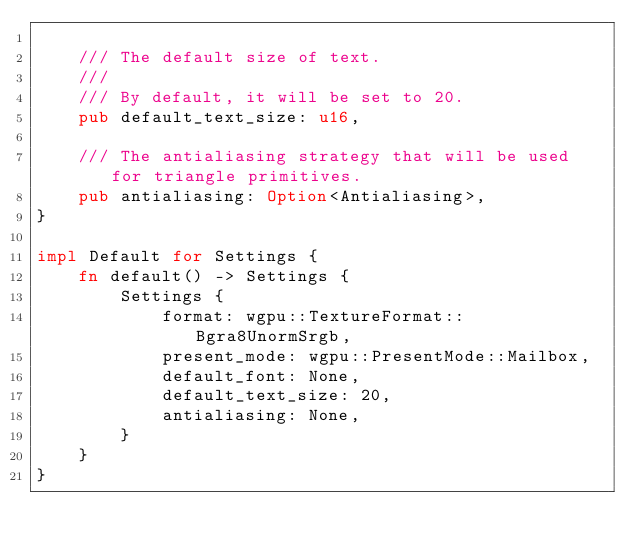Convert code to text. <code><loc_0><loc_0><loc_500><loc_500><_Rust_>
    /// The default size of text.
    ///
    /// By default, it will be set to 20.
    pub default_text_size: u16,

    /// The antialiasing strategy that will be used for triangle primitives.
    pub antialiasing: Option<Antialiasing>,
}

impl Default for Settings {
    fn default() -> Settings {
        Settings {
            format: wgpu::TextureFormat::Bgra8UnormSrgb,
            present_mode: wgpu::PresentMode::Mailbox,
            default_font: None,
            default_text_size: 20,
            antialiasing: None,
        }
    }
}
</code> 